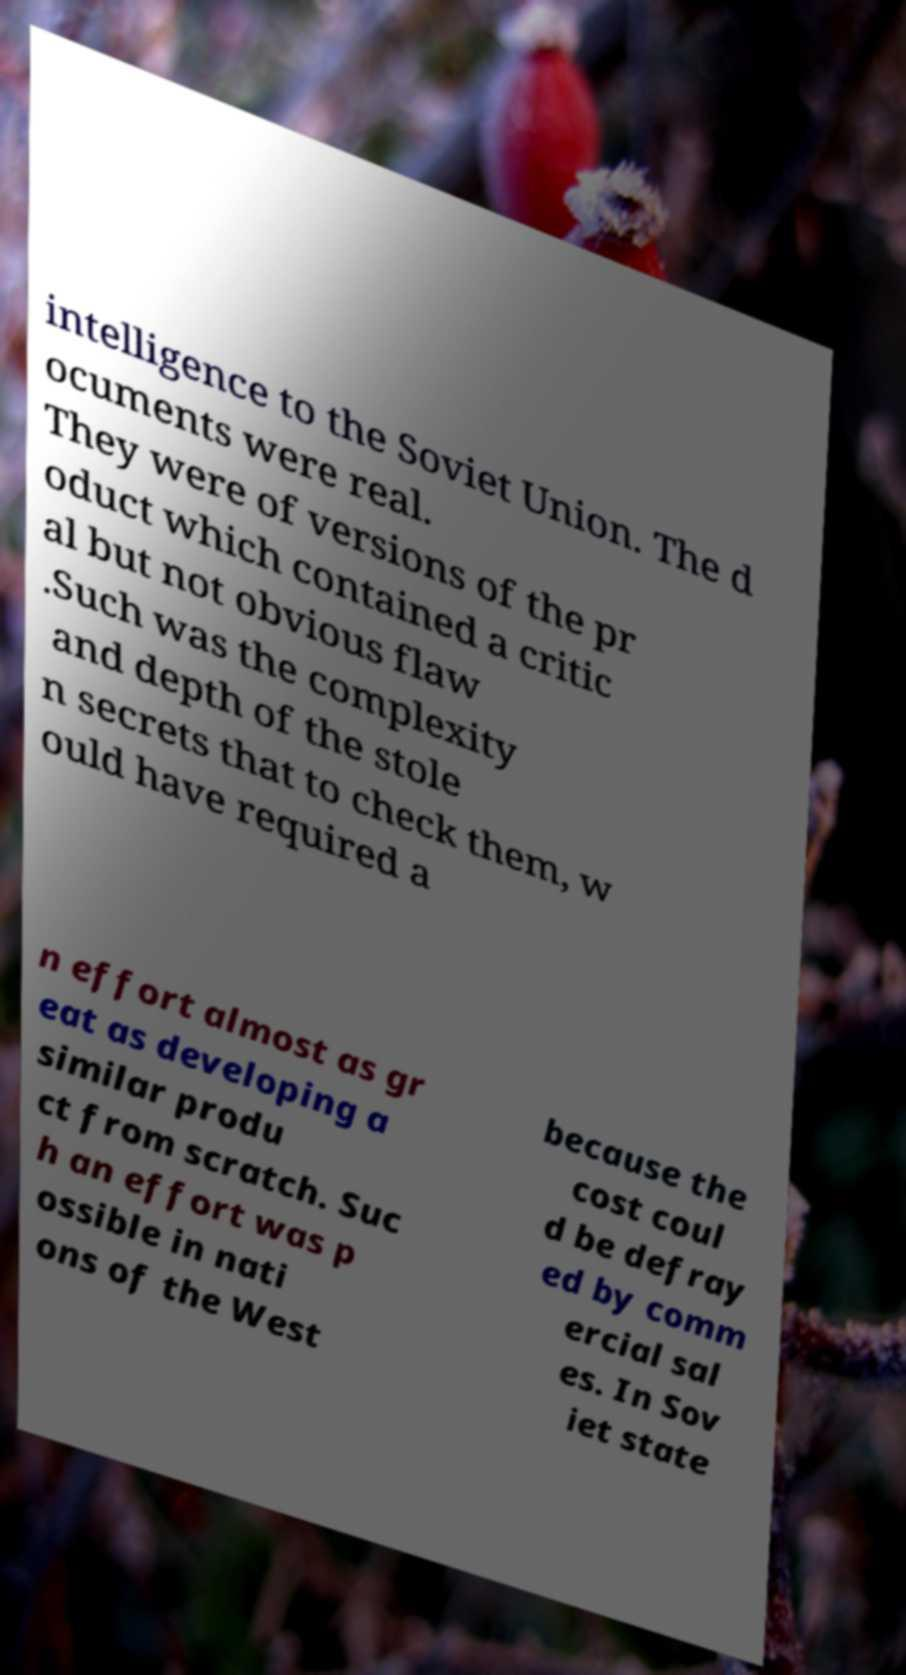Please read and relay the text visible in this image. What does it say? intelligence to the Soviet Union. The d ocuments were real. They were of versions of the pr oduct which contained a critic al but not obvious flaw .Such was the complexity and depth of the stole n secrets that to check them, w ould have required a n effort almost as gr eat as developing a similar produ ct from scratch. Suc h an effort was p ossible in nati ons of the West because the cost coul d be defray ed by comm ercial sal es. In Sov iet state 